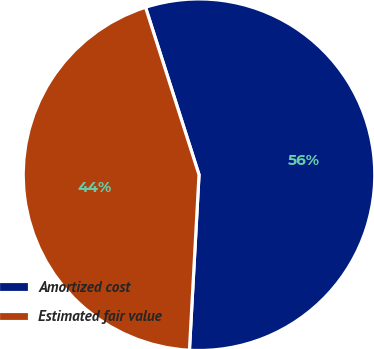Convert chart. <chart><loc_0><loc_0><loc_500><loc_500><pie_chart><fcel>Amortized cost<fcel>Estimated fair value<nl><fcel>55.79%<fcel>44.21%<nl></chart> 